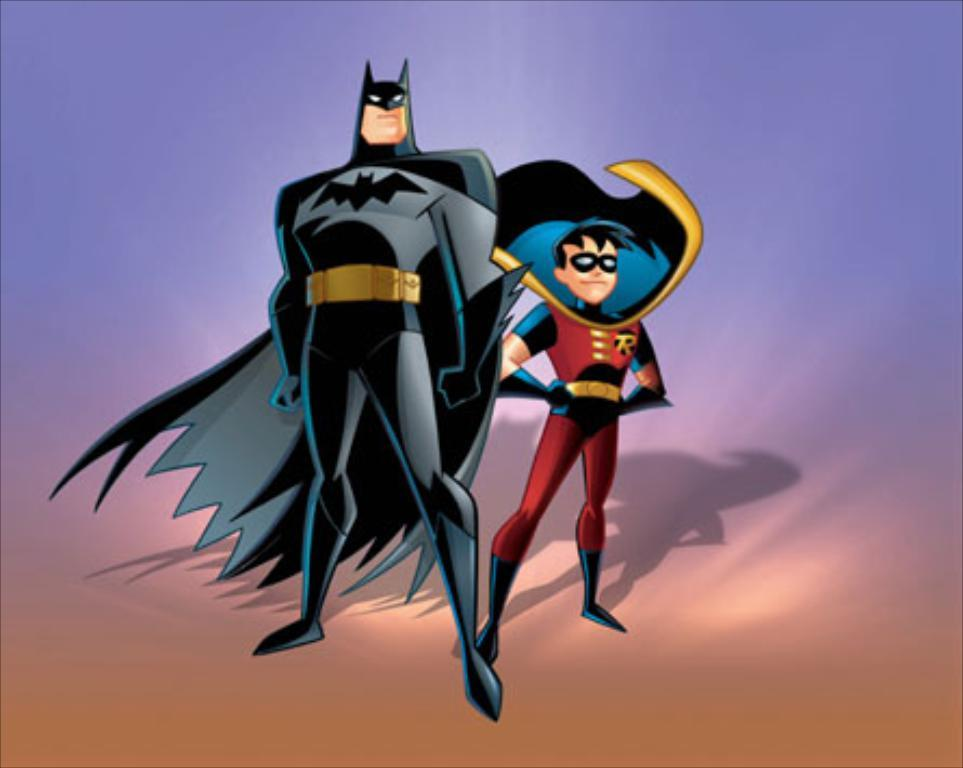What type of image is being described? The image is animated. What can be found within the animated image? There are animated characters in the image. What type of soap is being used by the secretary in the image? There is no soap or secretary present in the image; it only contains animated characters. 